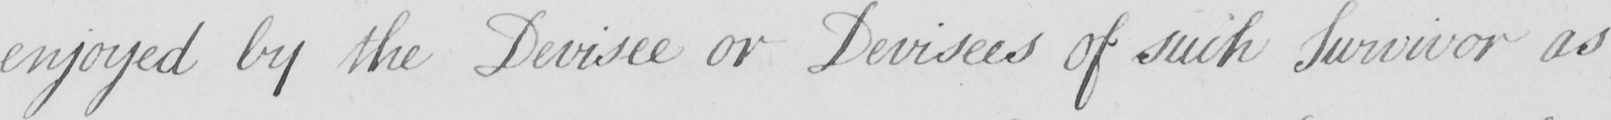Please provide the text content of this handwritten line. enjoyed by the Devisee or Devisees of such Survivor as 